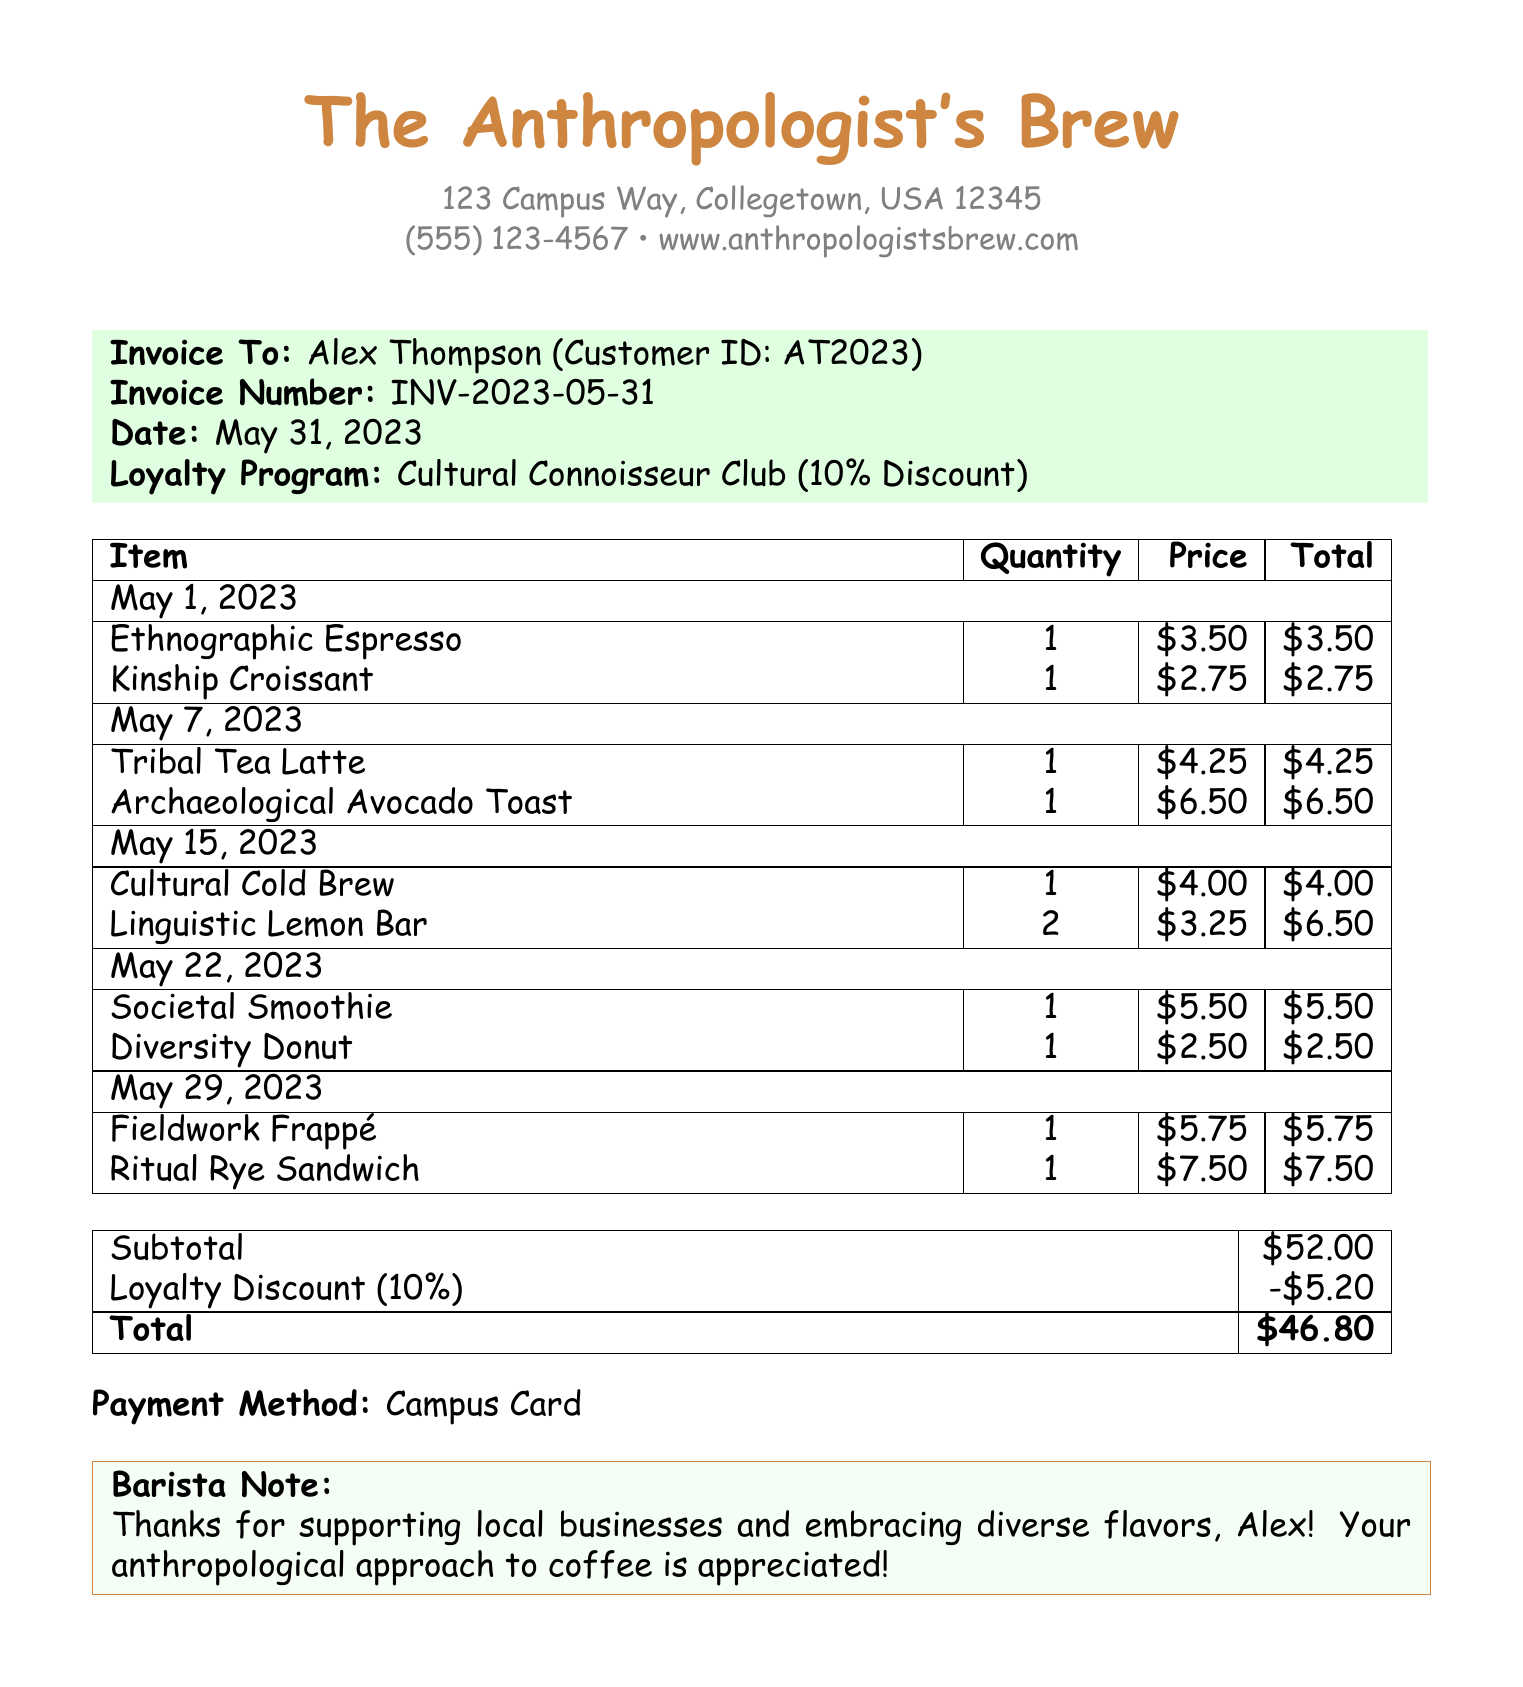What is the name of the coffee shop? The name of the coffee shop is listed at the top of the document.
Answer: The Anthropologist's Brew What is the invoice number? The invoice number is clearly stated in the document under the invoice details.
Answer: INV-2023-05-31 How much is the loyalty discount? The loyalty discount percentage is mentioned in relation to the loyalty program.
Answer: 10% What was the total amount charged? The total amount is displayed in the totals section of the invoice.
Answer: $46.80 How many items were purchased on May 15, 2023? The number of items can be found by counting the entries under the corresponding date.
Answer: 2 What is the subtotal before the discount? The subtotal before applying the loyalty discount is listed separately in the totals section.
Answer: $52.00 What payment method was used? The payment method is stated towards the end of the document.
Answer: Campus Card Which item was purchased for $2.50? The item price is detailed under the items purchased section for each date.
Answer: Diversity Donut What is the barista's note to the customer? The note is included in a highlighted box at the bottom of the invoice.
Answer: Thanks for supporting local businesses and embracing diverse flavors, Alex! Your anthropological approach to coffee is appreciated! 